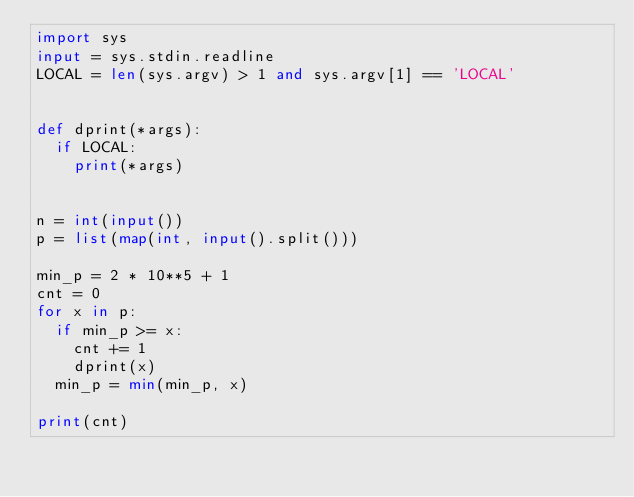Convert code to text. <code><loc_0><loc_0><loc_500><loc_500><_Python_>import sys
input = sys.stdin.readline
LOCAL = len(sys.argv) > 1 and sys.argv[1] == 'LOCAL'


def dprint(*args):
  if LOCAL:
    print(*args)


n = int(input())
p = list(map(int, input().split()))

min_p = 2 * 10**5 + 1
cnt = 0
for x in p:
  if min_p >= x:
    cnt += 1
    dprint(x)
  min_p = min(min_p, x)

print(cnt)
</code> 